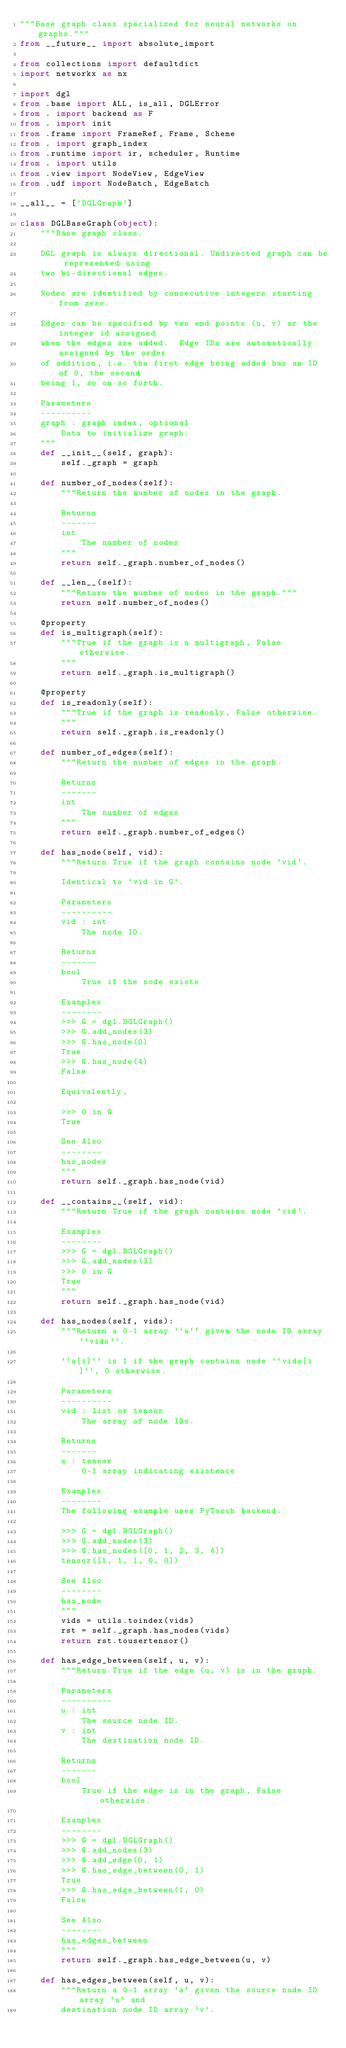<code> <loc_0><loc_0><loc_500><loc_500><_Python_>"""Base graph class specialized for neural networks on graphs."""
from __future__ import absolute_import

from collections import defaultdict
import networkx as nx

import dgl
from .base import ALL, is_all, DGLError
from . import backend as F
from . import init
from .frame import FrameRef, Frame, Scheme
from . import graph_index
from .runtime import ir, scheduler, Runtime
from . import utils
from .view import NodeView, EdgeView
from .udf import NodeBatch, EdgeBatch

__all__ = ['DGLGraph']

class DGLBaseGraph(object):
    """Base graph class.

    DGL graph is always directional. Undirected graph can be represented using
    two bi-directional edges.

    Nodes are identified by consecutive integers starting from zero.

    Edges can be specified by two end points (u, v) or the integer id assigned
    when the edges are added.  Edge IDs are automatically assigned by the order
    of addition, i.e. the first edge being added has an ID of 0, the second
    being 1, so on so forth.

    Parameters
    ----------
    graph : graph index, optional
        Data to initialize graph.
    """
    def __init__(self, graph):
        self._graph = graph

    def number_of_nodes(self):
        """Return the number of nodes in the graph.

        Returns
        -------
        int
            The number of nodes
        """
        return self._graph.number_of_nodes()

    def __len__(self):
        """Return the number of nodes in the graph."""
        return self.number_of_nodes()

    @property
    def is_multigraph(self):
        """True if the graph is a multigraph, False otherwise.
        """
        return self._graph.is_multigraph()

    @property
    def is_readonly(self):
        """True if the graph is readonly, False otherwise.
        """
        return self._graph.is_readonly()

    def number_of_edges(self):
        """Return the number of edges in the graph.

        Returns
        -------
        int
            The number of edges
        """
        return self._graph.number_of_edges()

    def has_node(self, vid):
        """Return True if the graph contains node `vid`.

        Identical to `vid in G`.

        Parameters
        ----------
        vid : int
            The node ID.

        Returns
        -------
        bool
            True if the node exists

        Examples
        --------
        >>> G = dgl.DGLGraph()
        >>> G.add_nodes(3)
        >>> G.has_node(0)
        True
        >>> G.has_node(4)
        False

        Equivalently,

        >>> 0 in G
        True

        See Also
        --------
        has_nodes
        """
        return self._graph.has_node(vid)

    def __contains__(self, vid):
        """Return True if the graph contains node `vid`.

        Examples
        --------
        >>> G = dgl.DGLGraph()
        >>> G.add_nodes(3)
        >>> 0 in G
        True
        """
        return self._graph.has_node(vid)

    def has_nodes(self, vids):
        """Return a 0-1 array ``a`` given the node ID array ``vids``.

        ``a[i]`` is 1 if the graph contains node ``vids[i]``, 0 otherwise.

        Parameters
        ----------
        vid : list or tensor
            The array of node IDs.

        Returns
        -------
        a : tensor
            0-1 array indicating existence

        Examples
        --------
        The following example uses PyTorch backend.

        >>> G = dgl.DGLGraph()
        >>> G.add_nodes(3)
        >>> G.has_nodes([0, 1, 2, 3, 4])
        tensor([1, 1, 1, 0, 0])

        See Also
        --------
        has_node
        """
        vids = utils.toindex(vids)
        rst = self._graph.has_nodes(vids)
        return rst.tousertensor()

    def has_edge_between(self, u, v):
        """Return True if the edge (u, v) is in the graph.

        Parameters
        ----------
        u : int
            The source node ID.
        v : int
            The destination node ID.

        Returns
        -------
        bool
            True if the edge is in the graph, False otherwise.

        Examples
        --------
        >>> G = dgl.DGLGraph()
        >>> G.add_nodes(3)
        >>> G.add_edge(0, 1)
        >>> G.has_edge_between(0, 1)
        True
        >>> G.has_edge_between(1, 0)
        False

        See Also
        --------
        has_edges_between
        """
        return self._graph.has_edge_between(u, v)

    def has_edges_between(self, u, v):
        """Return a 0-1 array `a` given the source node ID array `u` and
        destination node ID array `v`.
</code> 